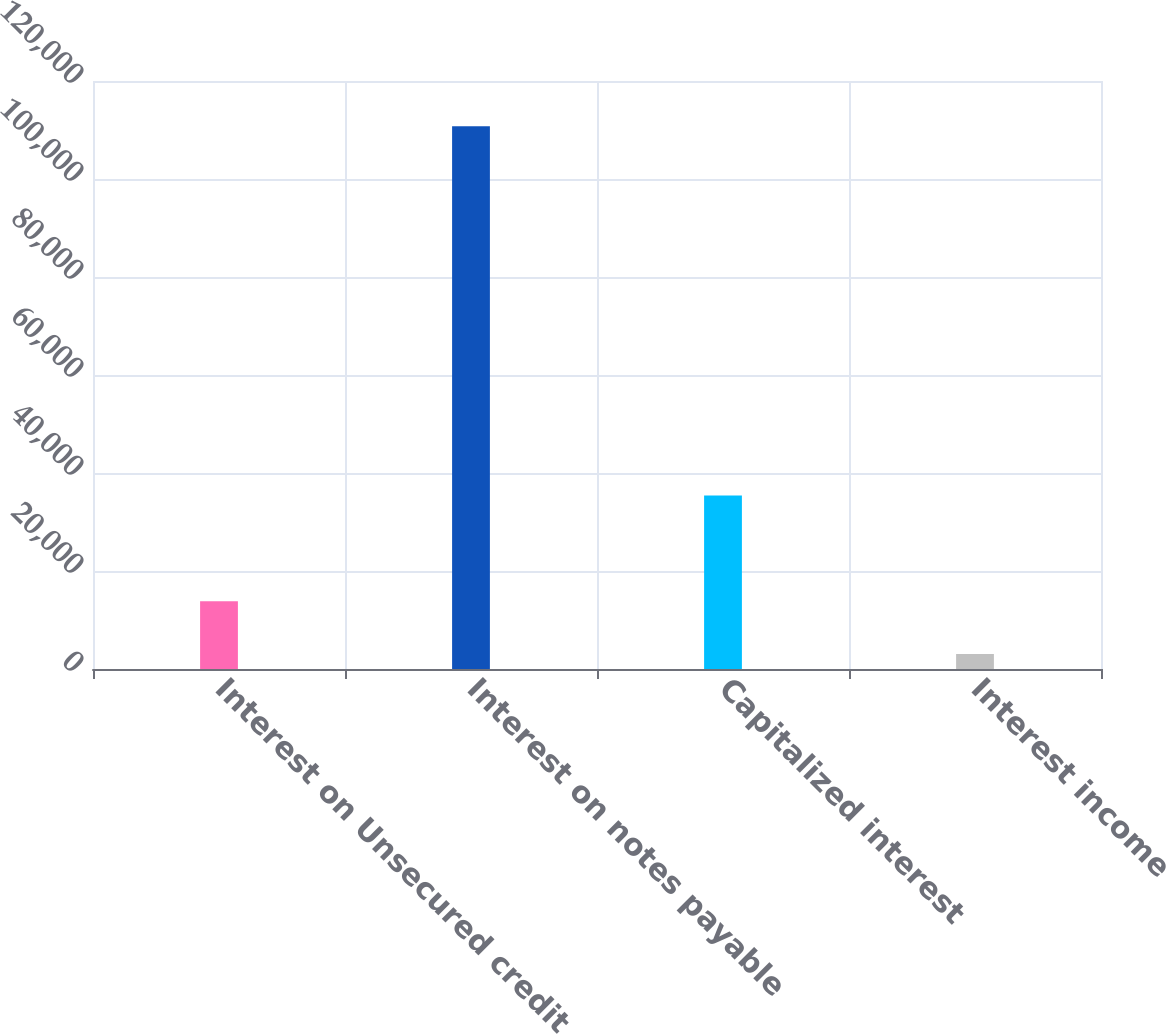Convert chart. <chart><loc_0><loc_0><loc_500><loc_500><bar_chart><fcel>Interest on Unsecured credit<fcel>Interest on notes payable<fcel>Capitalized interest<fcel>Interest income<nl><fcel>13848.6<fcel>110775<fcel>35424<fcel>3079<nl></chart> 